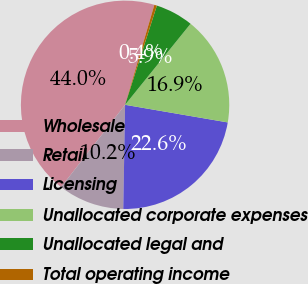<chart> <loc_0><loc_0><loc_500><loc_500><pie_chart><fcel>Wholesale<fcel>Retail<fcel>Licensing<fcel>Unallocated corporate expenses<fcel>Unallocated legal and<fcel>Total operating income<nl><fcel>44.02%<fcel>10.24%<fcel>22.57%<fcel>16.89%<fcel>5.88%<fcel>0.4%<nl></chart> 